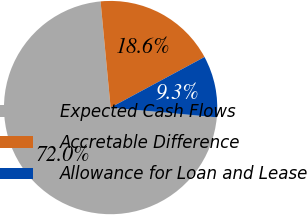Convert chart. <chart><loc_0><loc_0><loc_500><loc_500><pie_chart><fcel>Expected Cash Flows<fcel>Accretable Difference<fcel>Allowance for Loan and Lease<nl><fcel>72.03%<fcel>18.64%<fcel>9.32%<nl></chart> 